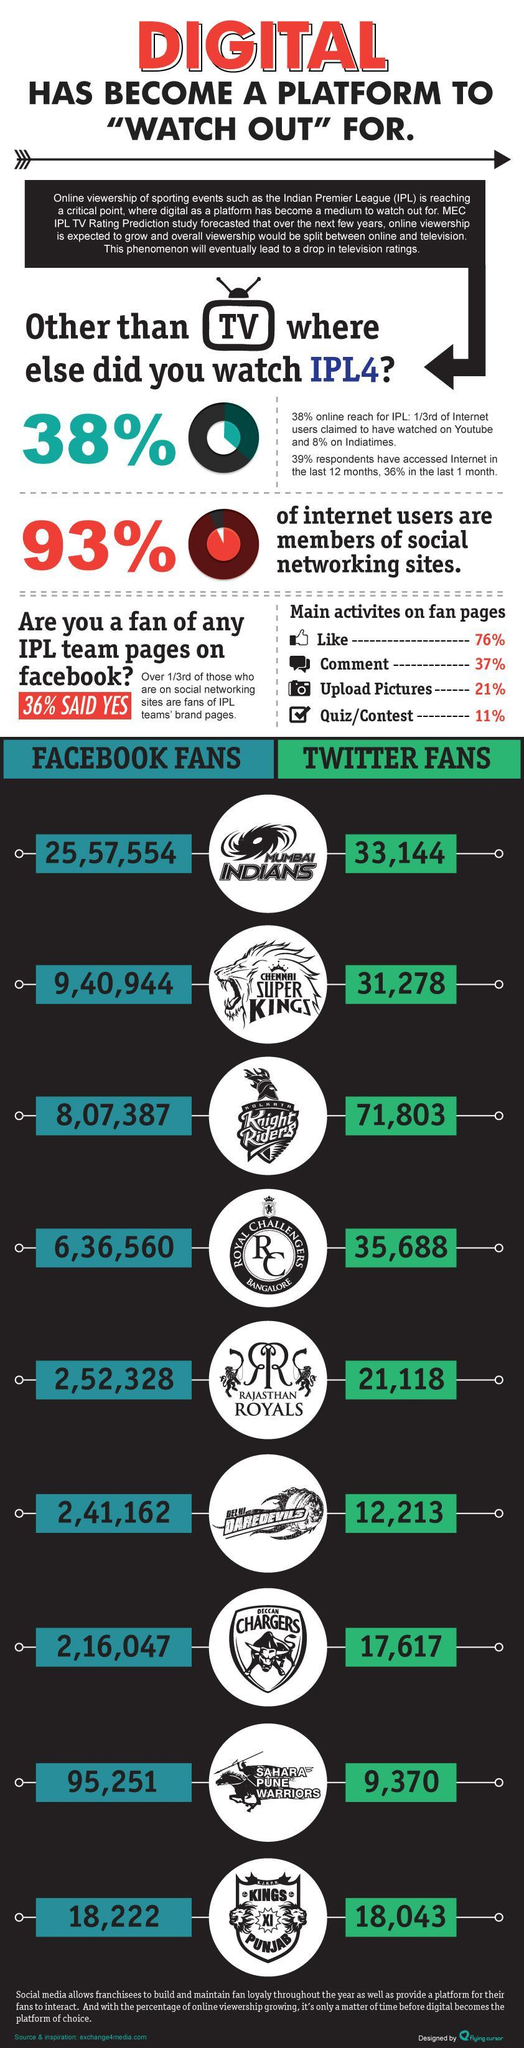What is the total number of Kolkata knight riders fans together on Facebook and Twitter?
Answer the question with a short phrase. 879190 What is the percentage of like and comment, taken together? 113% What is the total number of Chennai super fans together on Facebook and Twitter? 972222 What is the percentage of uploaded pictures and quiz, taken together? 32% What is the total number of Mumbai Indians fans together on Facebook and Twitter? 2590698 